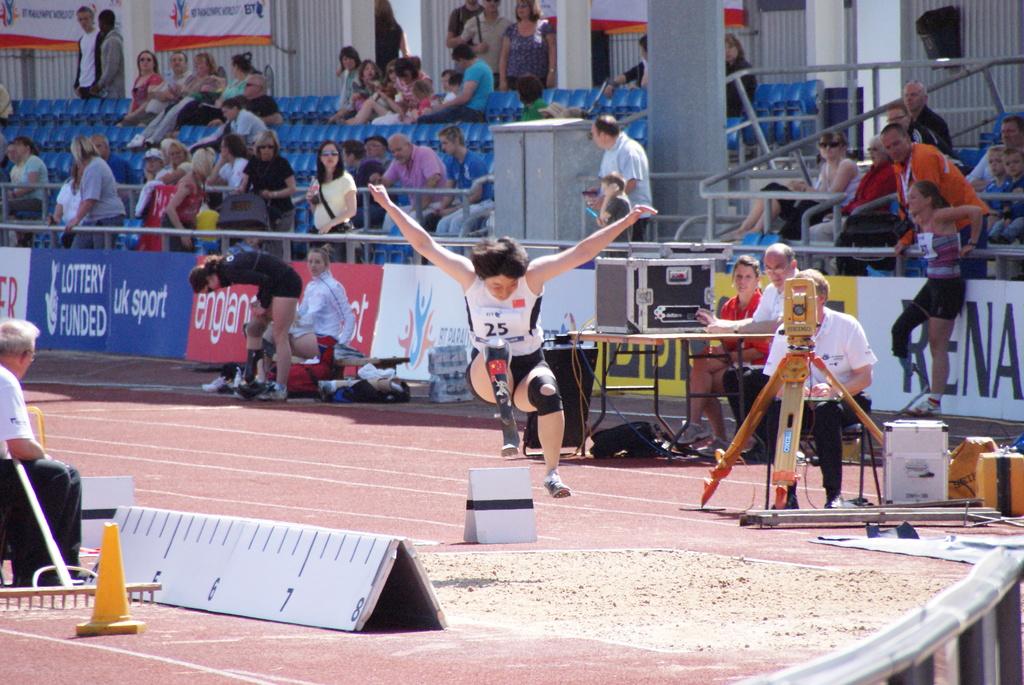What color is the cone?
Give a very brief answer. Yellow. What is the highest number on the measuring board?
Offer a terse response. 8. 